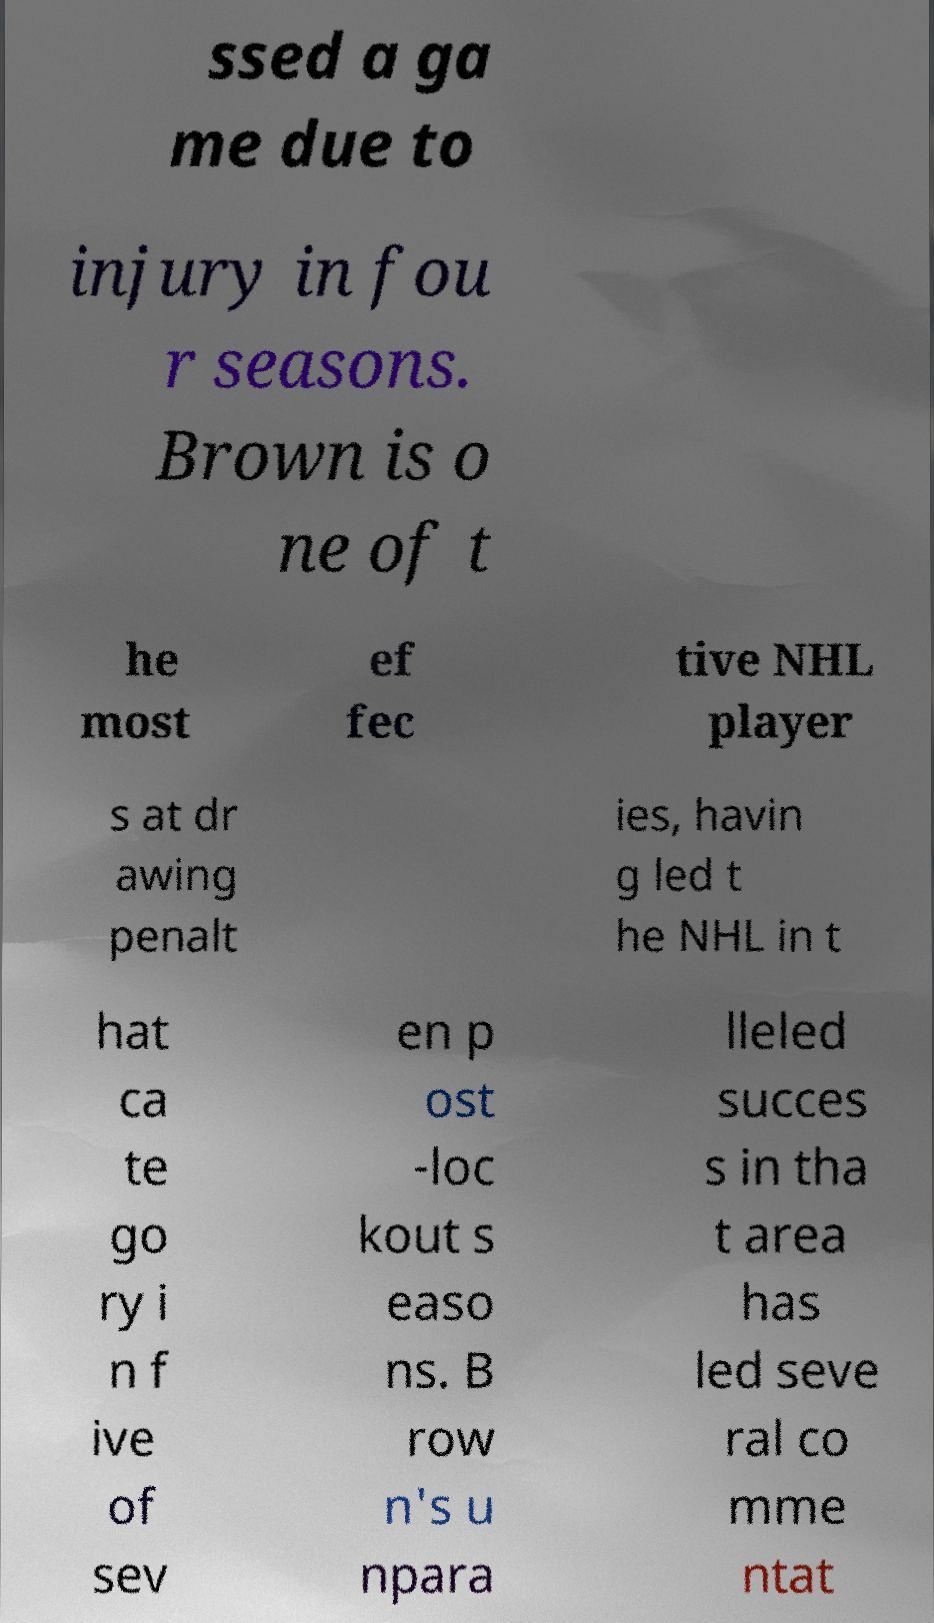Can you accurately transcribe the text from the provided image for me? ssed a ga me due to injury in fou r seasons. Brown is o ne of t he most ef fec tive NHL player s at dr awing penalt ies, havin g led t he NHL in t hat ca te go ry i n f ive of sev en p ost -loc kout s easo ns. B row n's u npara lleled succes s in tha t area has led seve ral co mme ntat 